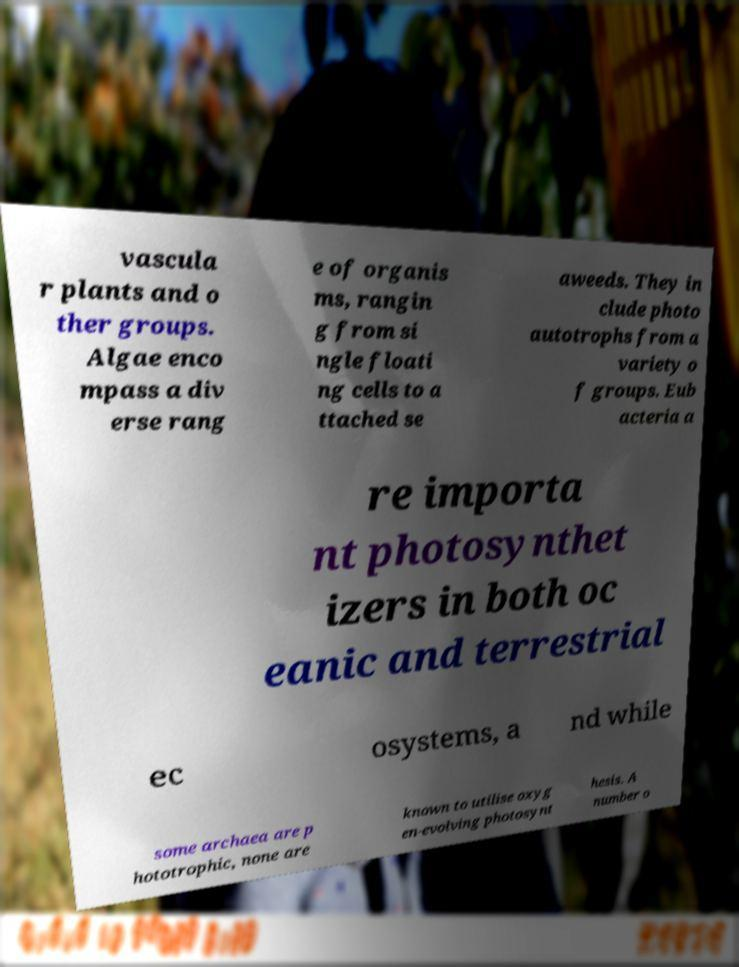What messages or text are displayed in this image? I need them in a readable, typed format. vascula r plants and o ther groups. Algae enco mpass a div erse rang e of organis ms, rangin g from si ngle floati ng cells to a ttached se aweeds. They in clude photo autotrophs from a variety o f groups. Eub acteria a re importa nt photosynthet izers in both oc eanic and terrestrial ec osystems, a nd while some archaea are p hototrophic, none are known to utilise oxyg en-evolving photosynt hesis. A number o 